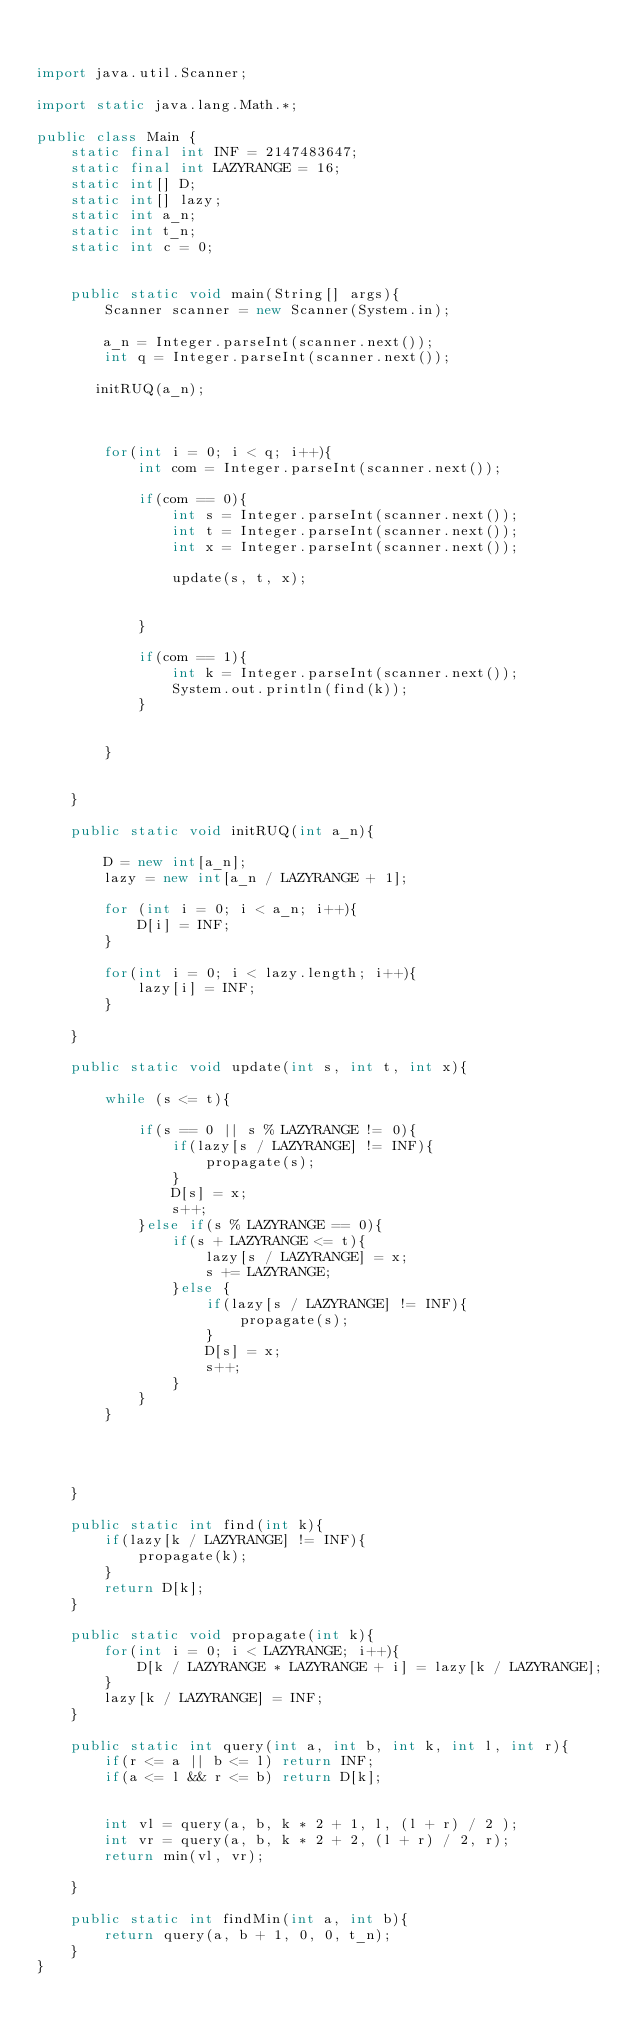Convert code to text. <code><loc_0><loc_0><loc_500><loc_500><_Java_>

import java.util.Scanner;

import static java.lang.Math.*;

public class Main {
    static final int INF = 2147483647;
    static final int LAZYRANGE = 16;
    static int[] D;
    static int[] lazy;
    static int a_n;
    static int t_n;
    static int c = 0;


    public static void main(String[] args){
        Scanner scanner = new Scanner(System.in);

        a_n = Integer.parseInt(scanner.next());
        int q = Integer.parseInt(scanner.next());

       initRUQ(a_n);



        for(int i = 0; i < q; i++){
            int com = Integer.parseInt(scanner.next());

            if(com == 0){
                int s = Integer.parseInt(scanner.next());
                int t = Integer.parseInt(scanner.next());
                int x = Integer.parseInt(scanner.next());

                update(s, t, x);


            }

            if(com == 1){
                int k = Integer.parseInt(scanner.next());
                System.out.println(find(k));
            }


        }


    }

    public static void initRUQ(int a_n){

        D = new int[a_n];
        lazy = new int[a_n / LAZYRANGE + 1];

        for (int i = 0; i < a_n; i++){
            D[i] = INF;
        }

        for(int i = 0; i < lazy.length; i++){
            lazy[i] = INF;
        }

    }

    public static void update(int s, int t, int x){

        while (s <= t){

            if(s == 0 || s % LAZYRANGE != 0){
                if(lazy[s / LAZYRANGE] != INF){
                    propagate(s);
                }
                D[s] = x;
                s++;
            }else if(s % LAZYRANGE == 0){
                if(s + LAZYRANGE <= t){
                    lazy[s / LAZYRANGE] = x;
                    s += LAZYRANGE;
                }else {
                    if(lazy[s / LAZYRANGE] != INF){
                        propagate(s);
                    }
                    D[s] = x;
                    s++;
                }
            }
        }




    }

    public static int find(int k){
        if(lazy[k / LAZYRANGE] != INF){
            propagate(k);
        }
        return D[k];
    }

    public static void propagate(int k){
        for(int i = 0; i < LAZYRANGE; i++){
            D[k / LAZYRANGE * LAZYRANGE + i] = lazy[k / LAZYRANGE];
        }
        lazy[k / LAZYRANGE] = INF;
    }

    public static int query(int a, int b, int k, int l, int r){
        if(r <= a || b <= l) return INF;
        if(a <= l && r <= b) return D[k];


        int vl = query(a, b, k * 2 + 1, l, (l + r) / 2 );
        int vr = query(a, b, k * 2 + 2, (l + r) / 2, r);
        return min(vl, vr);

    }

    public static int findMin(int a, int b){
        return query(a, b + 1, 0, 0, t_n);
    }
}
</code> 